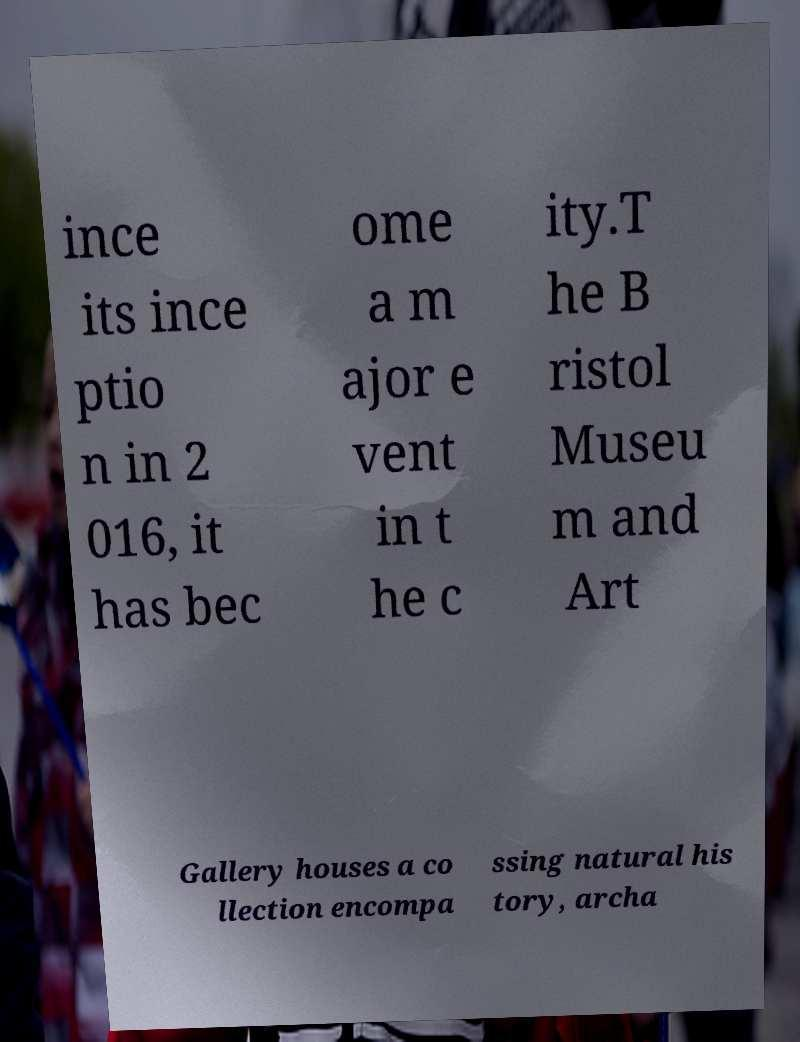Could you extract and type out the text from this image? ince its ince ptio n in 2 016, it has bec ome a m ajor e vent in t he c ity.T he B ristol Museu m and Art Gallery houses a co llection encompa ssing natural his tory, archa 